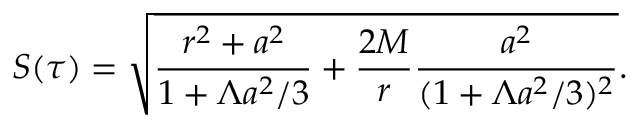Convert formula to latex. <formula><loc_0><loc_0><loc_500><loc_500>S ( \tau ) = \sqrt { \frac { r ^ { 2 } + a ^ { 2 } } { 1 + \Lambda a ^ { 2 } / 3 } + \frac { 2 M } { r } \frac { a ^ { 2 } } { ( 1 + \Lambda a ^ { 2 } / 3 ) ^ { 2 } } } .</formula> 